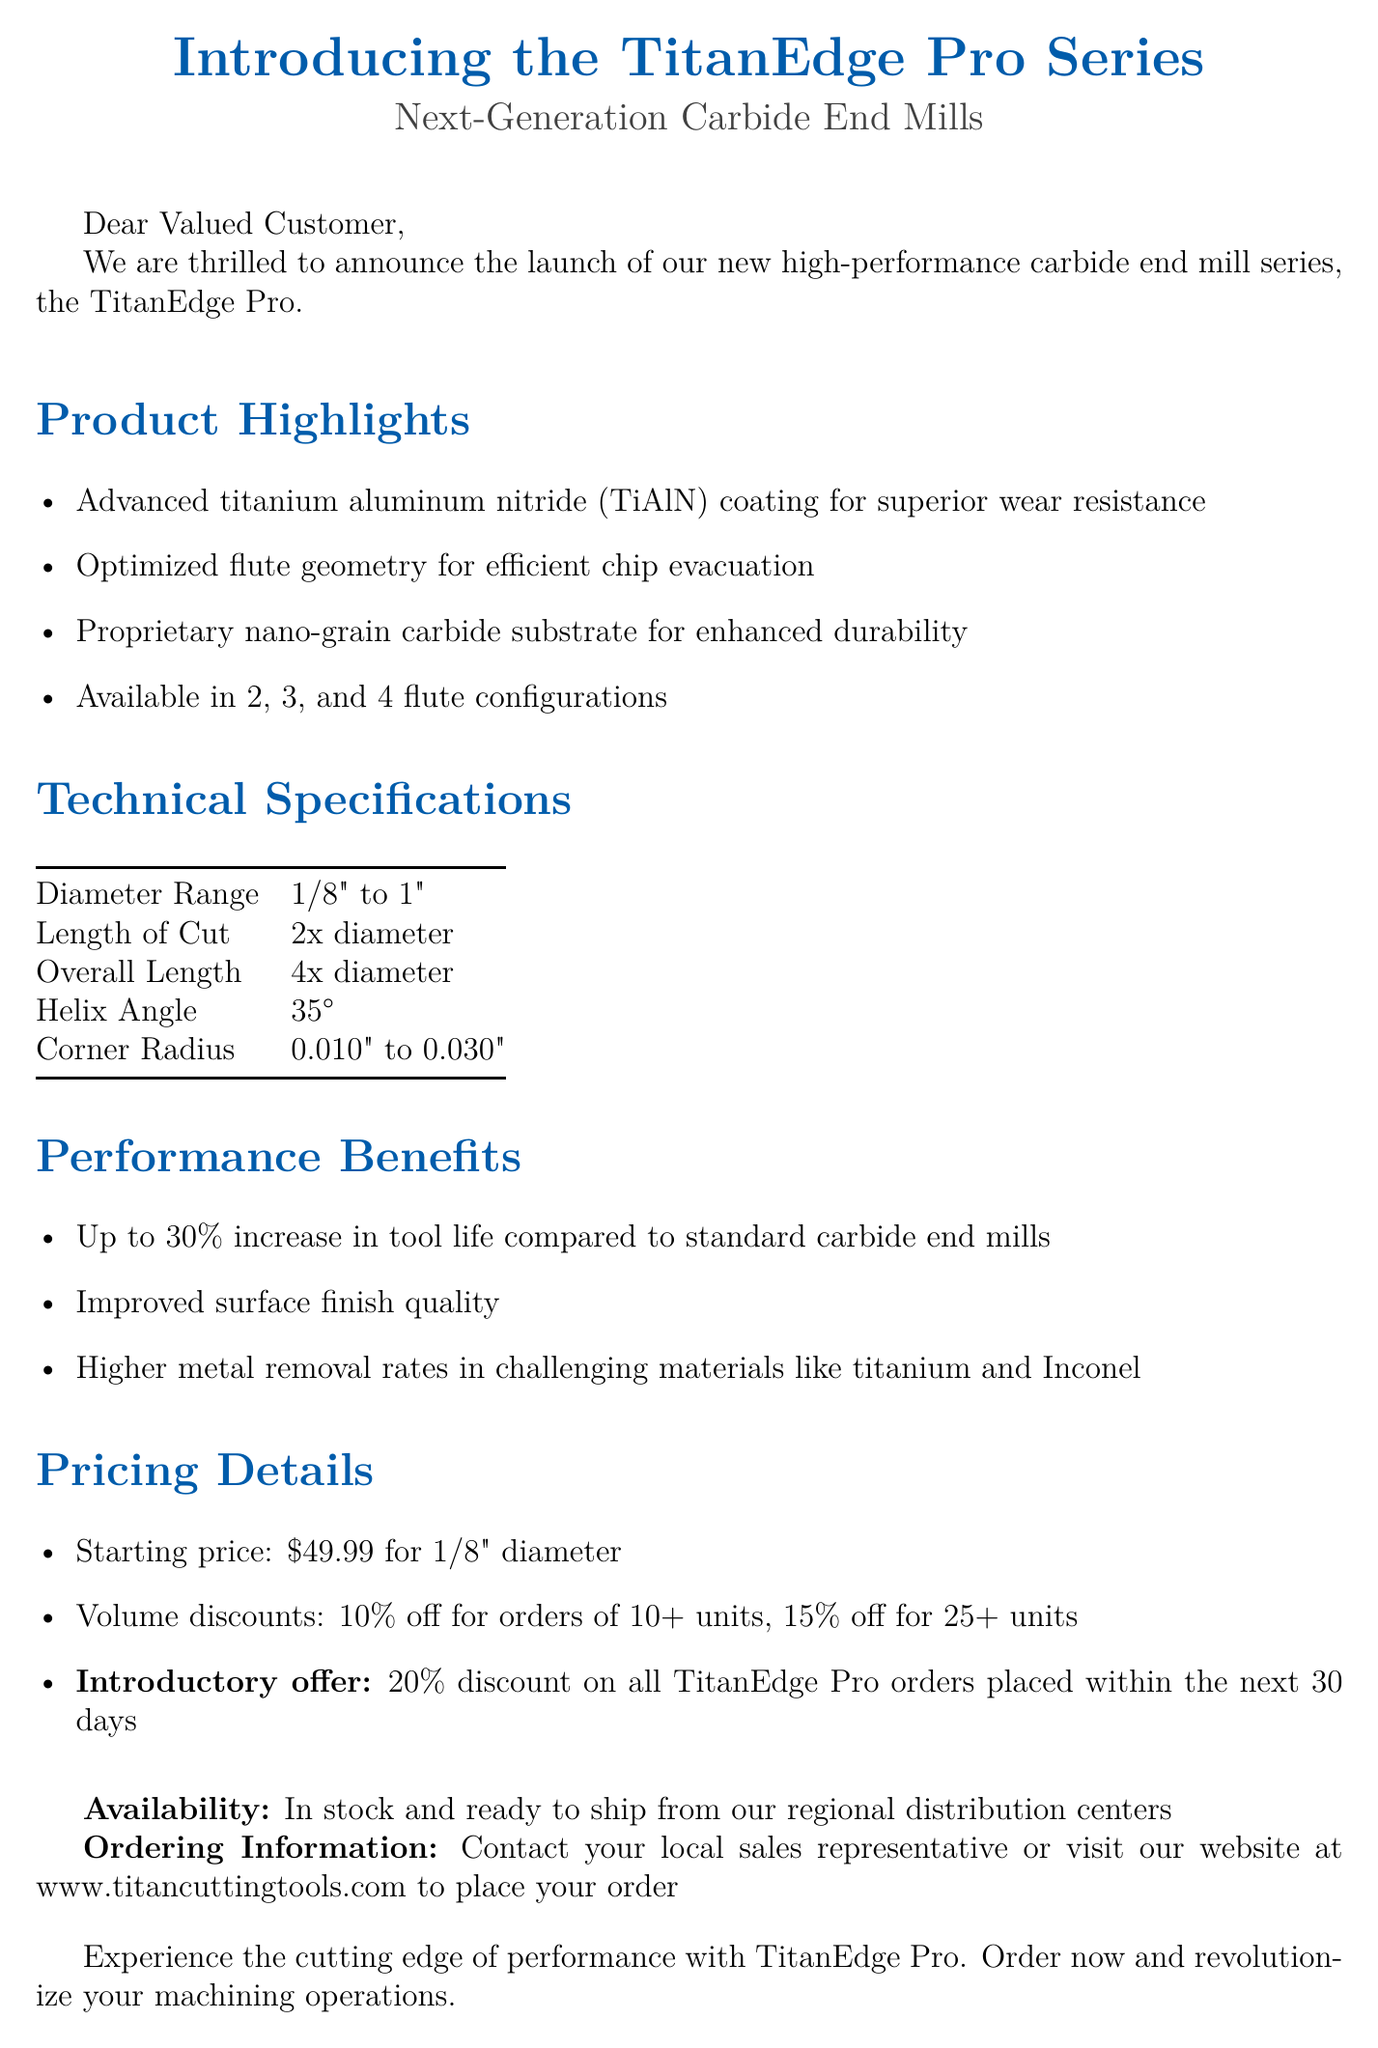What is the name of the new product series? The new product series is referred to as the TitanEdge Pro.
Answer: TitanEdge Pro What material coating is used in the TitanEdge Pro series? The coating used is advanced titanium aluminum nitride (TiAlN) for superior wear resistance.
Answer: titanium aluminum nitride (TiAlN) What is the diameter range of the carbide end mills? The document specifies that the diameter range is from 1/8" to 1".
Answer: 1/8" to 1" How many flute configurations are available for the TitanEdge Pro series? The end mills are available in 2, 3, and 4 flute configurations.
Answer: 2, 3, and 4 What is the starting price for the 1/8" diameter end mill? The starting price listed for the 1/8" diameter end mill is $49.99.
Answer: $49.99 What discount is offered for orders of 10 or more units? The document states there is a 10% off discount for orders of 10 or more units.
Answer: 10% off What is the introductory discount for orders placed within the next 30 days? An introductory offer of 20% discount is available for orders placed within the next 30 days.
Answer: 20% discount What is the helix angle of the TitanEdge Pro end mills? The helix angle specified for the end mills is 35 degrees.
Answer: 35° Which materials are highlighted for higher metal removal rates? The document mentions challenging materials like titanium and Inconel for higher metal removal rates.
Answer: titanium and Inconel How can customers place their orders? Customers can place their orders by contacting their local sales representative or visiting the website.
Answer: Contact local sales representative or visit the website 